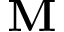<formula> <loc_0><loc_0><loc_500><loc_500>M</formula> 